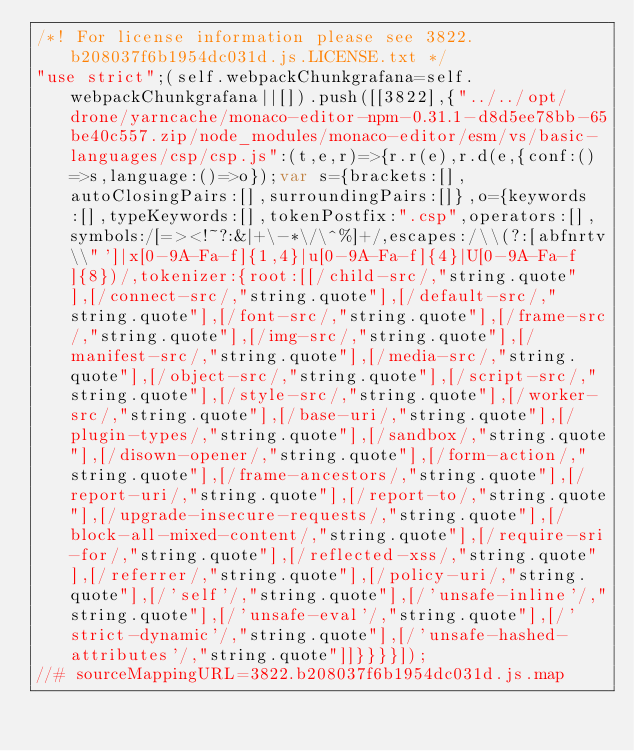Convert code to text. <code><loc_0><loc_0><loc_500><loc_500><_JavaScript_>/*! For license information please see 3822.b208037f6b1954dc031d.js.LICENSE.txt */
"use strict";(self.webpackChunkgrafana=self.webpackChunkgrafana||[]).push([[3822],{"../../opt/drone/yarncache/monaco-editor-npm-0.31.1-d8d5ee78bb-65be40c557.zip/node_modules/monaco-editor/esm/vs/basic-languages/csp/csp.js":(t,e,r)=>{r.r(e),r.d(e,{conf:()=>s,language:()=>o});var s={brackets:[],autoClosingPairs:[],surroundingPairs:[]},o={keywords:[],typeKeywords:[],tokenPostfix:".csp",operators:[],symbols:/[=><!~?:&|+\-*\/\^%]+/,escapes:/\\(?:[abfnrtv\\"']|x[0-9A-Fa-f]{1,4}|u[0-9A-Fa-f]{4}|U[0-9A-Fa-f]{8})/,tokenizer:{root:[[/child-src/,"string.quote"],[/connect-src/,"string.quote"],[/default-src/,"string.quote"],[/font-src/,"string.quote"],[/frame-src/,"string.quote"],[/img-src/,"string.quote"],[/manifest-src/,"string.quote"],[/media-src/,"string.quote"],[/object-src/,"string.quote"],[/script-src/,"string.quote"],[/style-src/,"string.quote"],[/worker-src/,"string.quote"],[/base-uri/,"string.quote"],[/plugin-types/,"string.quote"],[/sandbox/,"string.quote"],[/disown-opener/,"string.quote"],[/form-action/,"string.quote"],[/frame-ancestors/,"string.quote"],[/report-uri/,"string.quote"],[/report-to/,"string.quote"],[/upgrade-insecure-requests/,"string.quote"],[/block-all-mixed-content/,"string.quote"],[/require-sri-for/,"string.quote"],[/reflected-xss/,"string.quote"],[/referrer/,"string.quote"],[/policy-uri/,"string.quote"],[/'self'/,"string.quote"],[/'unsafe-inline'/,"string.quote"],[/'unsafe-eval'/,"string.quote"],[/'strict-dynamic'/,"string.quote"],[/'unsafe-hashed-attributes'/,"string.quote"]]}}}}]);
//# sourceMappingURL=3822.b208037f6b1954dc031d.js.map</code> 